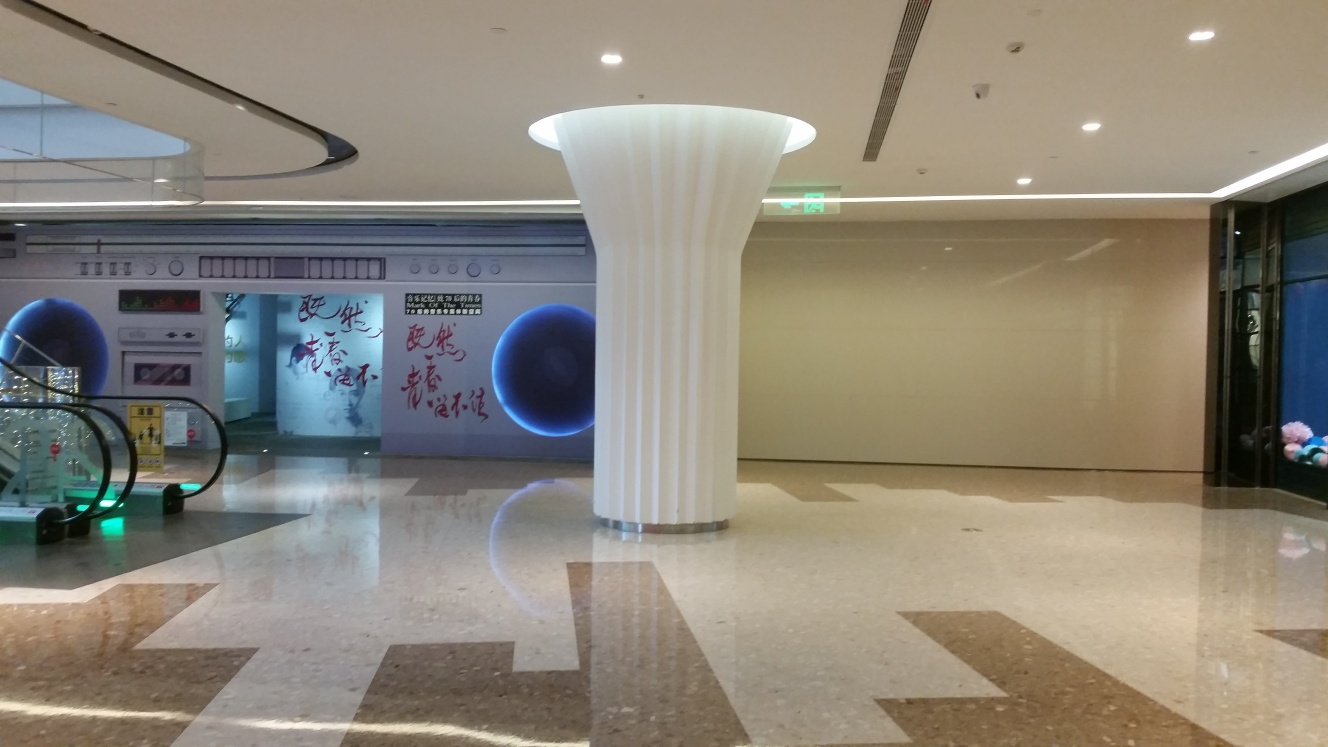What is the architectural style of the pillar in the center? The pillar has a contemporary design with clean lines and a minimalist aesthetic, likely intended to complement the modern and sleek interior of the building. 